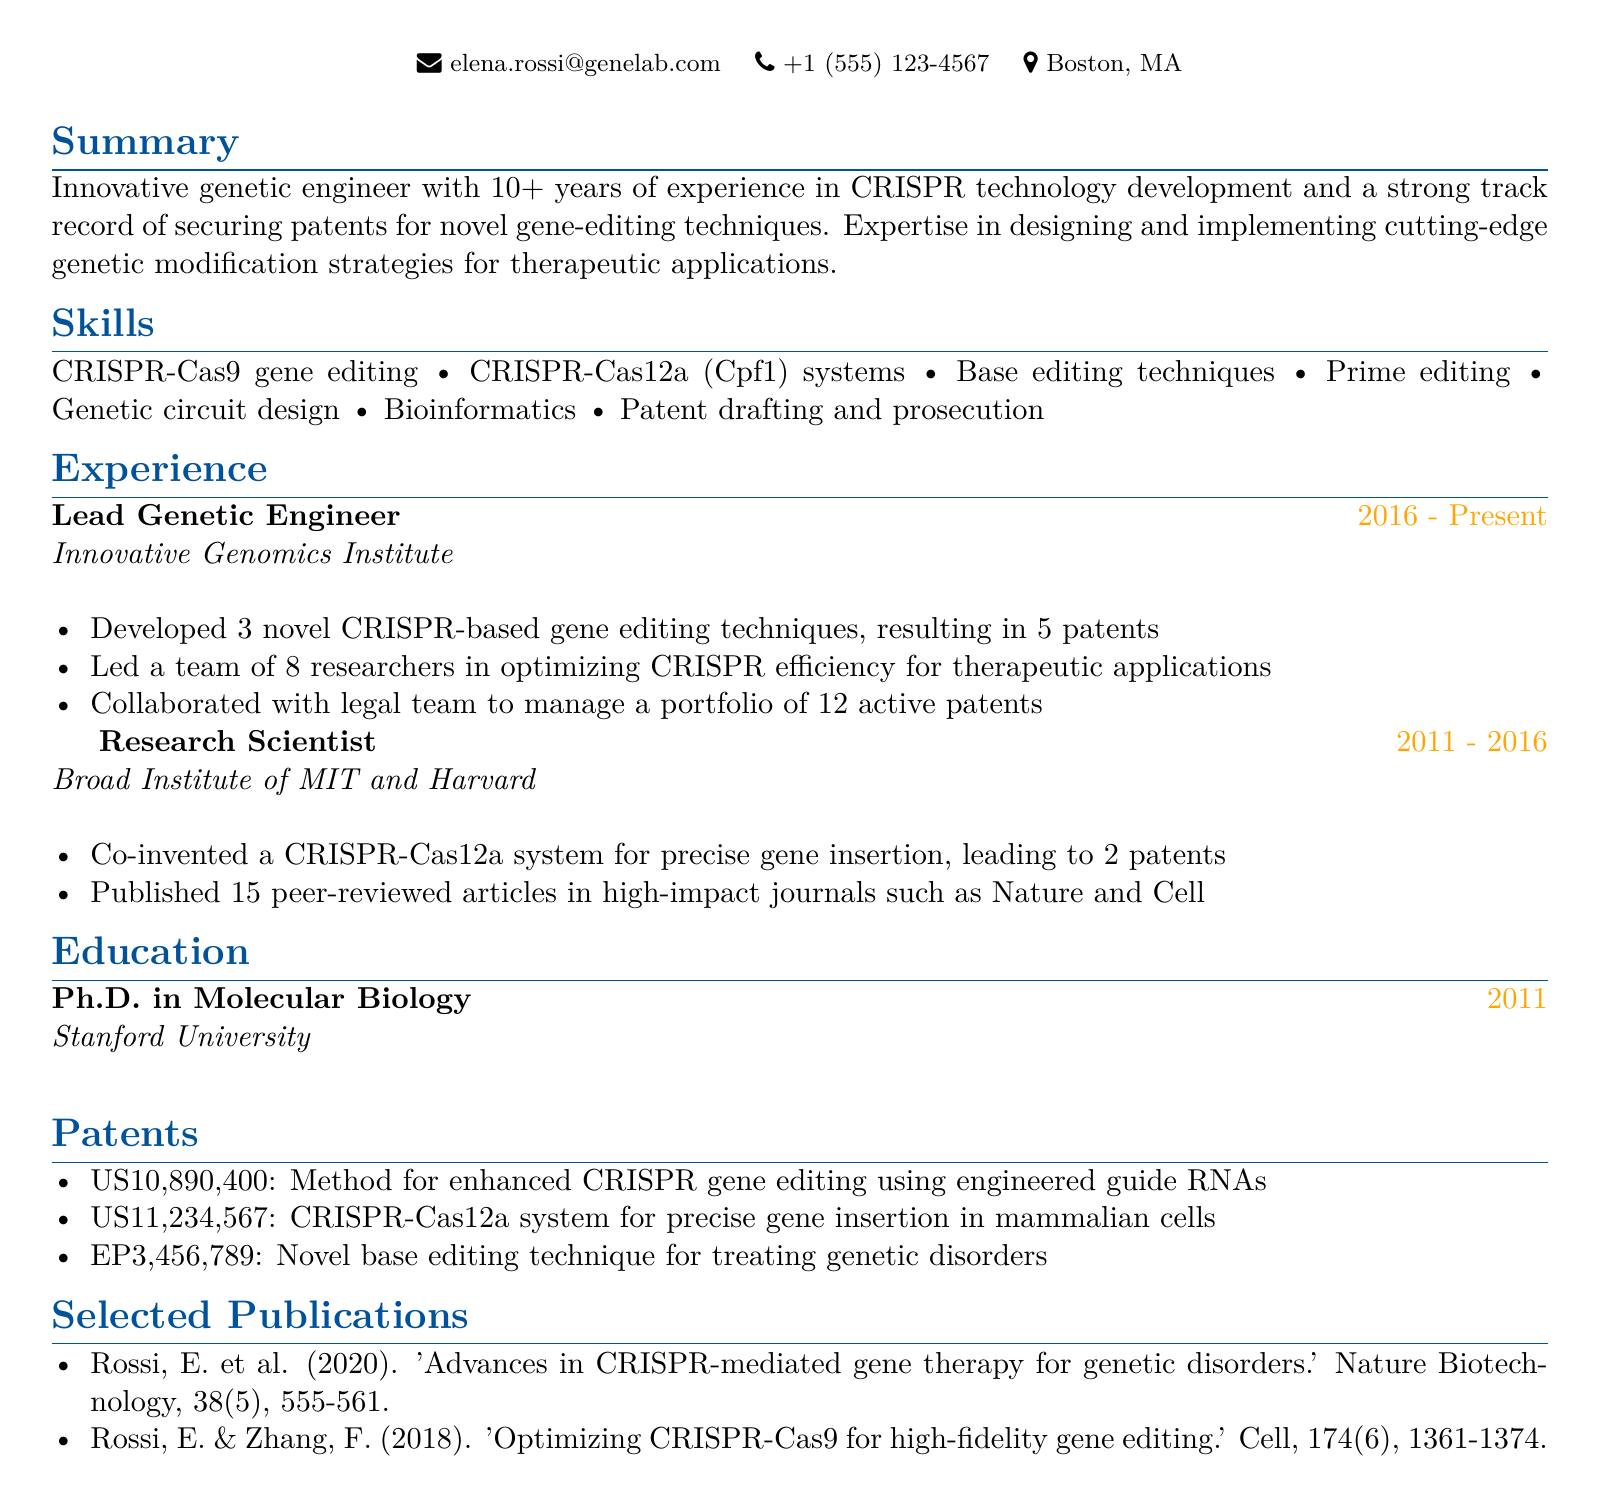What is the name of the individual? The name is listed in the personal information section of the document.
Answer: Dr. Elena Rossi What is the total number of patents secured? The total number of patents is the sum of those mentioned in the "Experience" and "Patents" sections, which are 5 and 3 respectively.
Answer: 8 What institution did Dr. Elena Rossi obtain her Ph.D. from? The education section specifies where Dr. Elena Rossi completed her degree.
Answer: Stanford University What is the main area of expertise mentioned in the summary? The summary highlights Dr. Rossi's primary focus and work in the field of genetics.
Answer: CRISPR technology During which years was Dr. Rossi a Research Scientist? The experience section indicates the duration of this role.
Answer: 2011 - 2016 How many publications are listed in the document? The selected publications section provides the count of published articles.
Answer: 2 What is the role of Dr. Rossi at the Innovative Genomics Institute? The experience section elaborates on Dr. Rossi's position at this company.
Answer: Lead Genetic Engineer Which journal featured the publication co-authored by Dr. Rossi in 2020? The listed publication provides the name of the journal.
Answer: Nature Biotechnology 